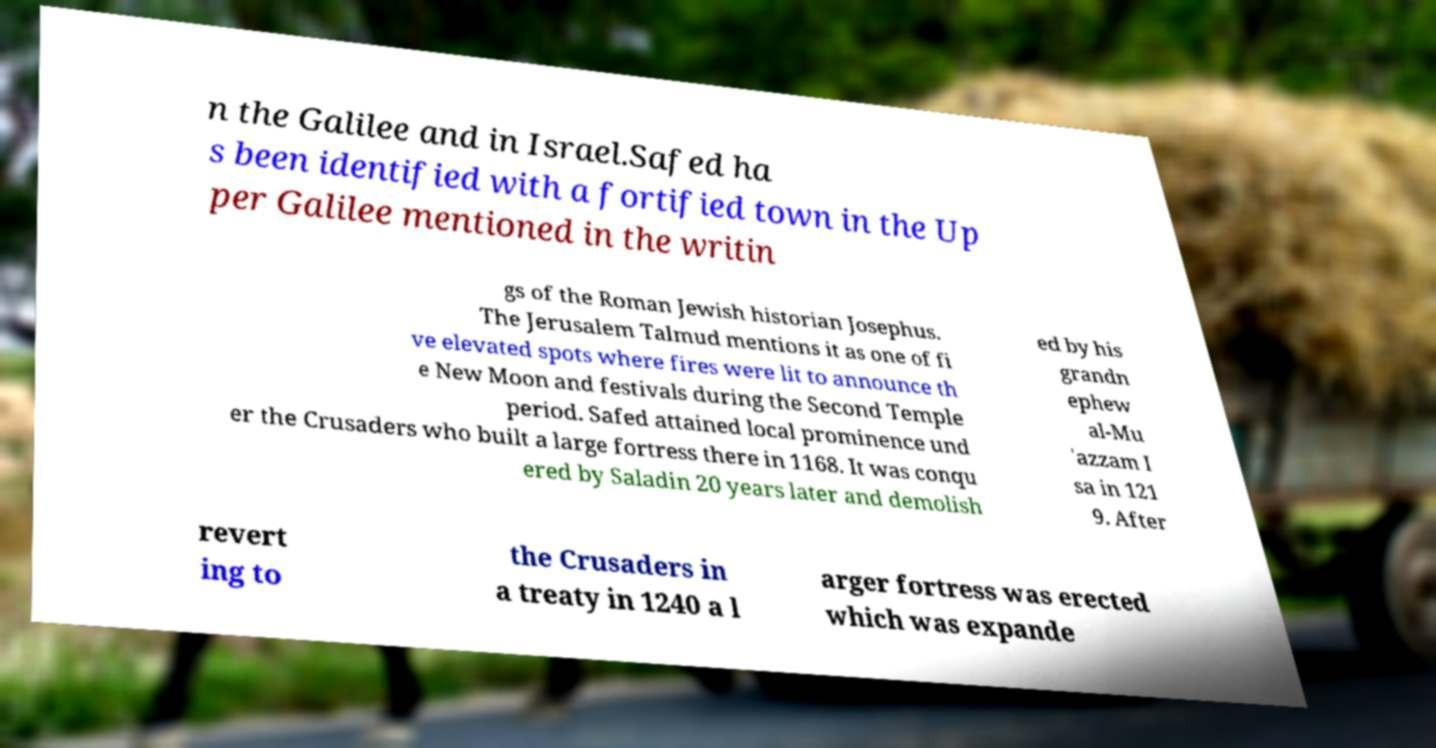There's text embedded in this image that I need extracted. Can you transcribe it verbatim? n the Galilee and in Israel.Safed ha s been identified with a fortified town in the Up per Galilee mentioned in the writin gs of the Roman Jewish historian Josephus. The Jerusalem Talmud mentions it as one of fi ve elevated spots where fires were lit to announce th e New Moon and festivals during the Second Temple period. Safed attained local prominence und er the Crusaders who built a large fortress there in 1168. It was conqu ered by Saladin 20 years later and demolish ed by his grandn ephew al-Mu 'azzam I sa in 121 9. After revert ing to the Crusaders in a treaty in 1240 a l arger fortress was erected which was expande 